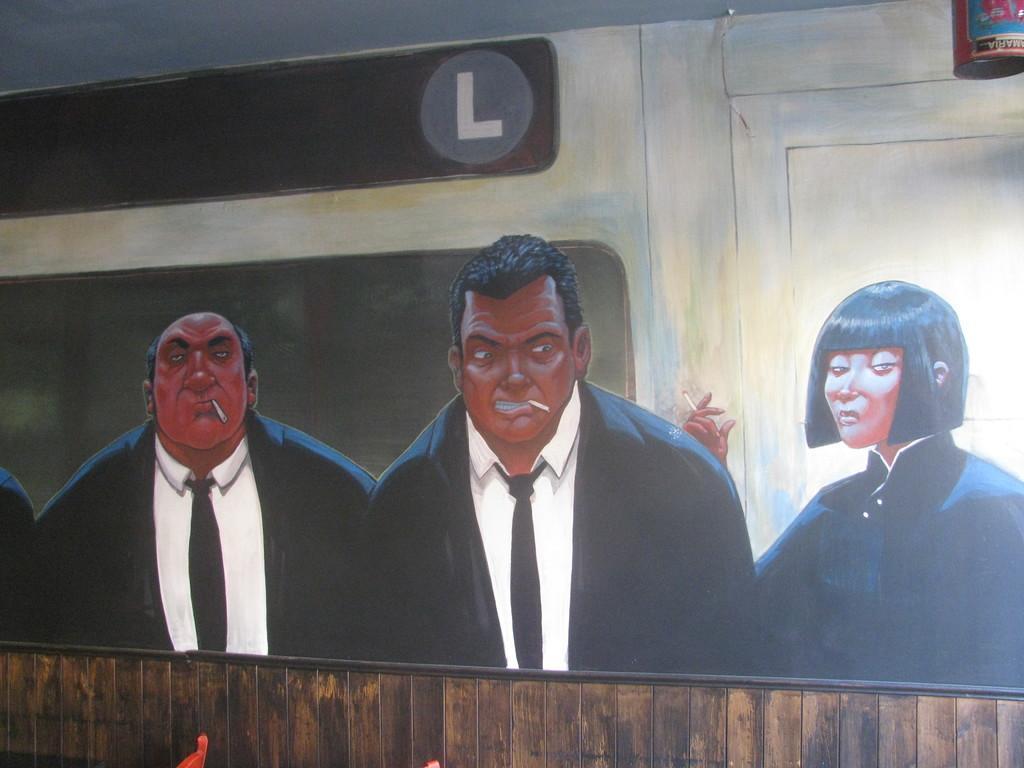Could you give a brief overview of what you see in this image? In this image we can see a picture on a wall containing two men and a woman holding the cigarettes. On the right corner we can see a container. 